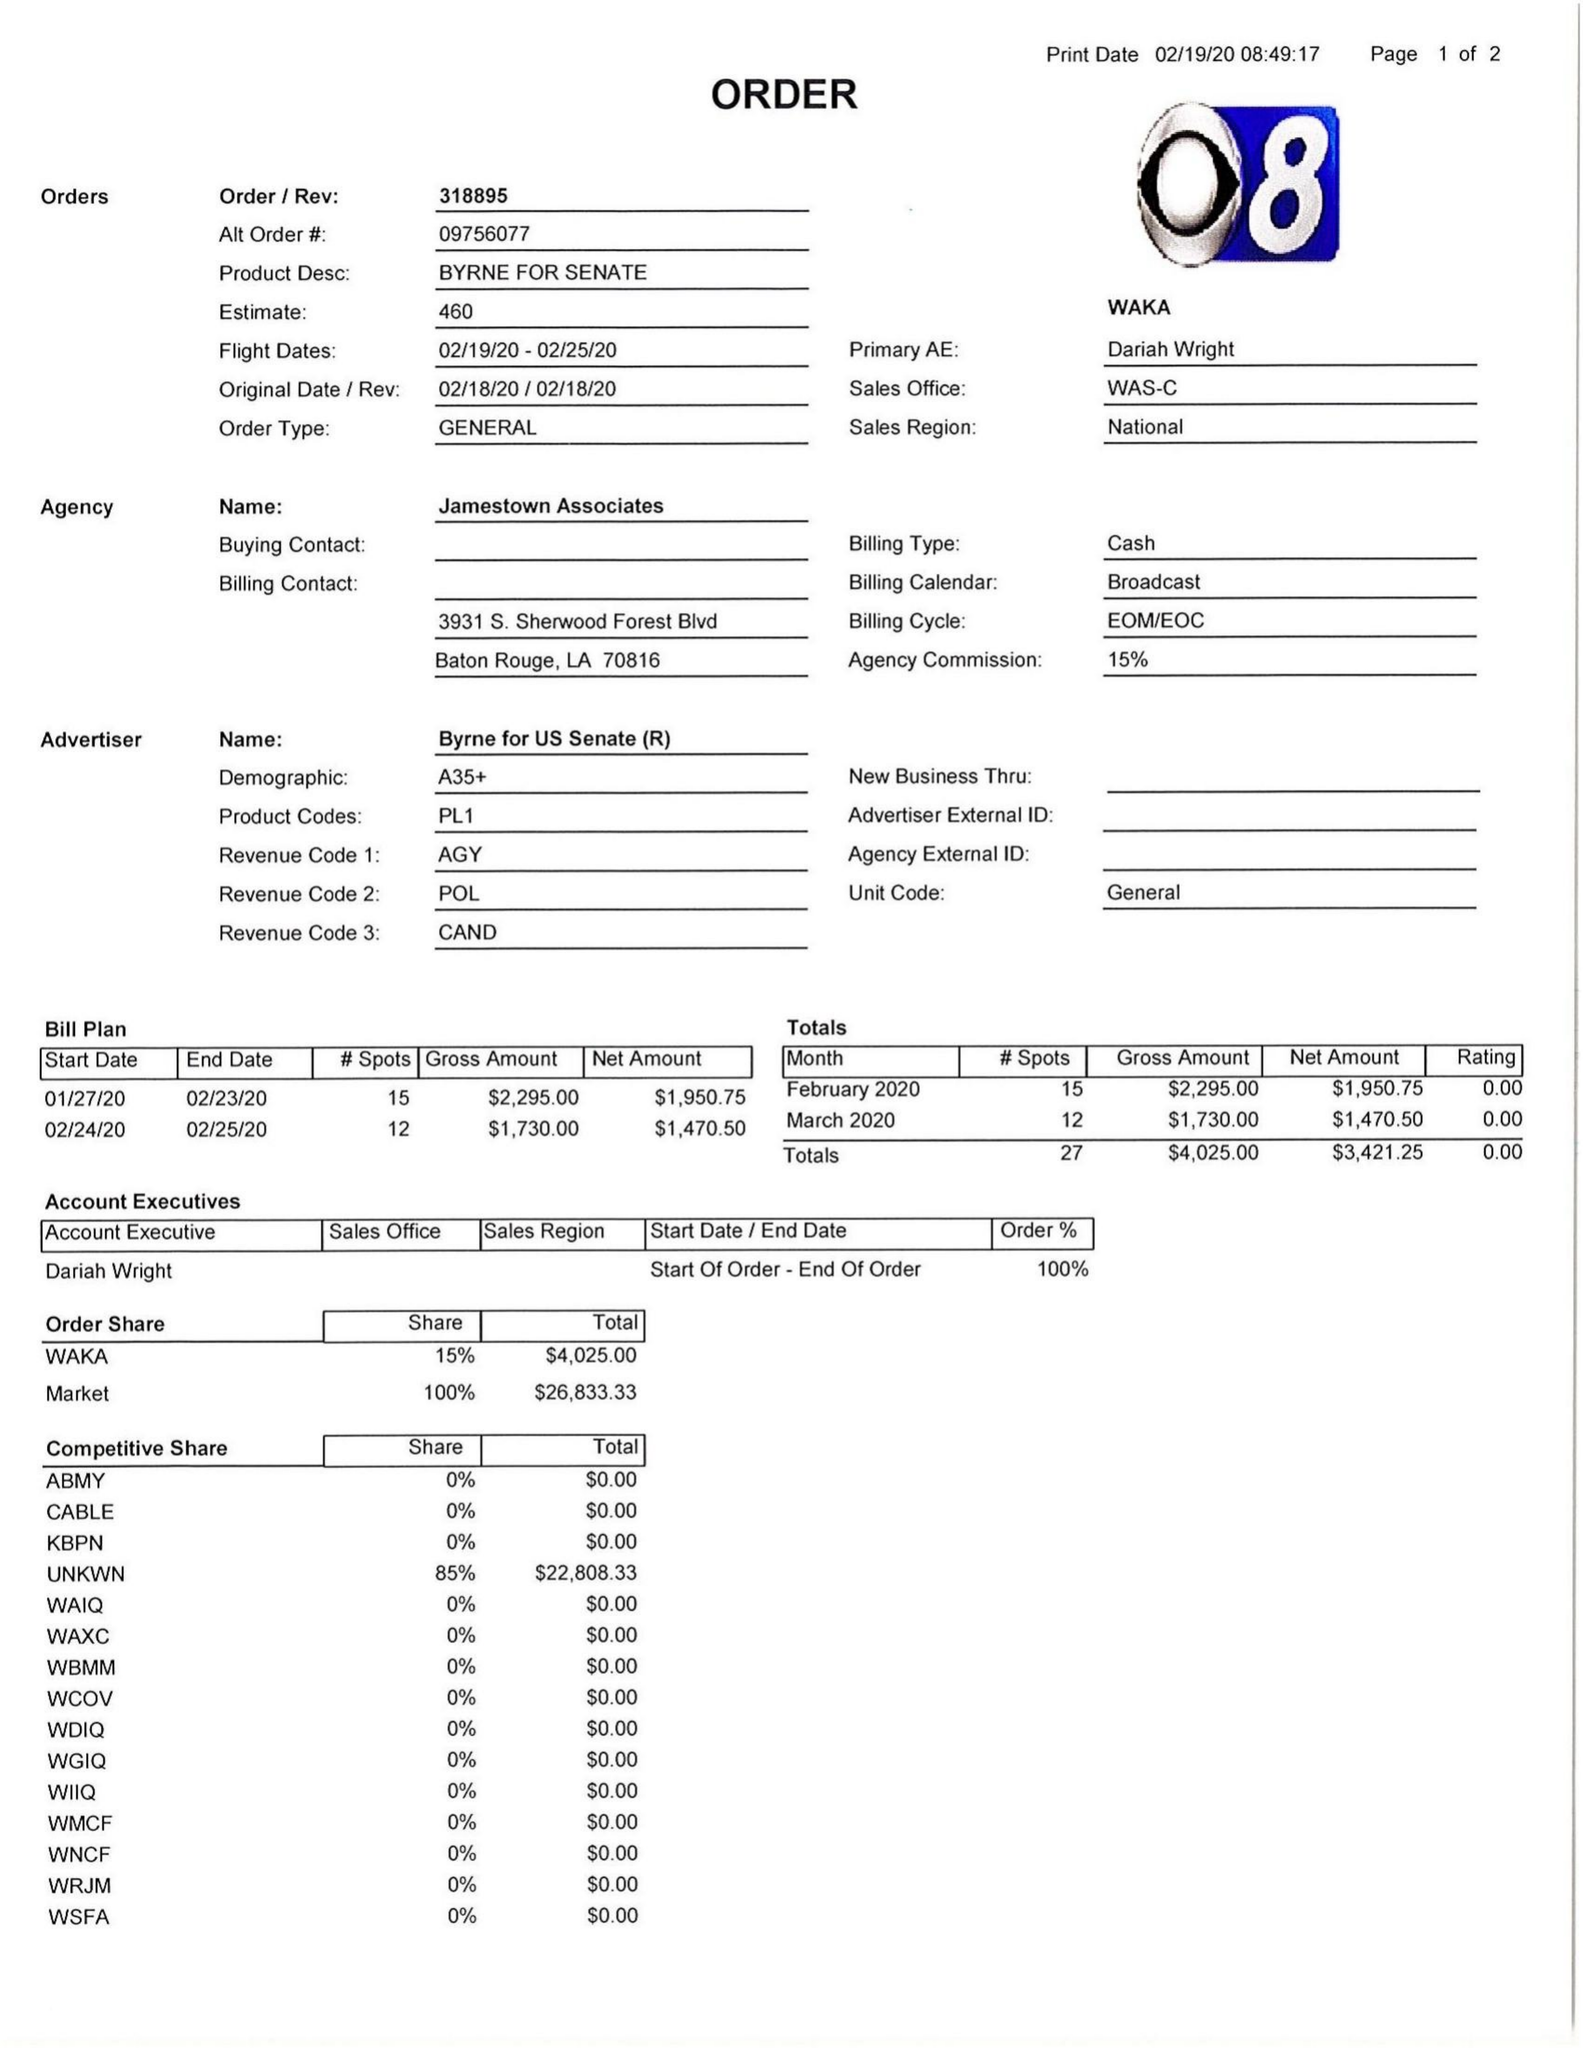What is the value for the contract_num?
Answer the question using a single word or phrase. 318895 